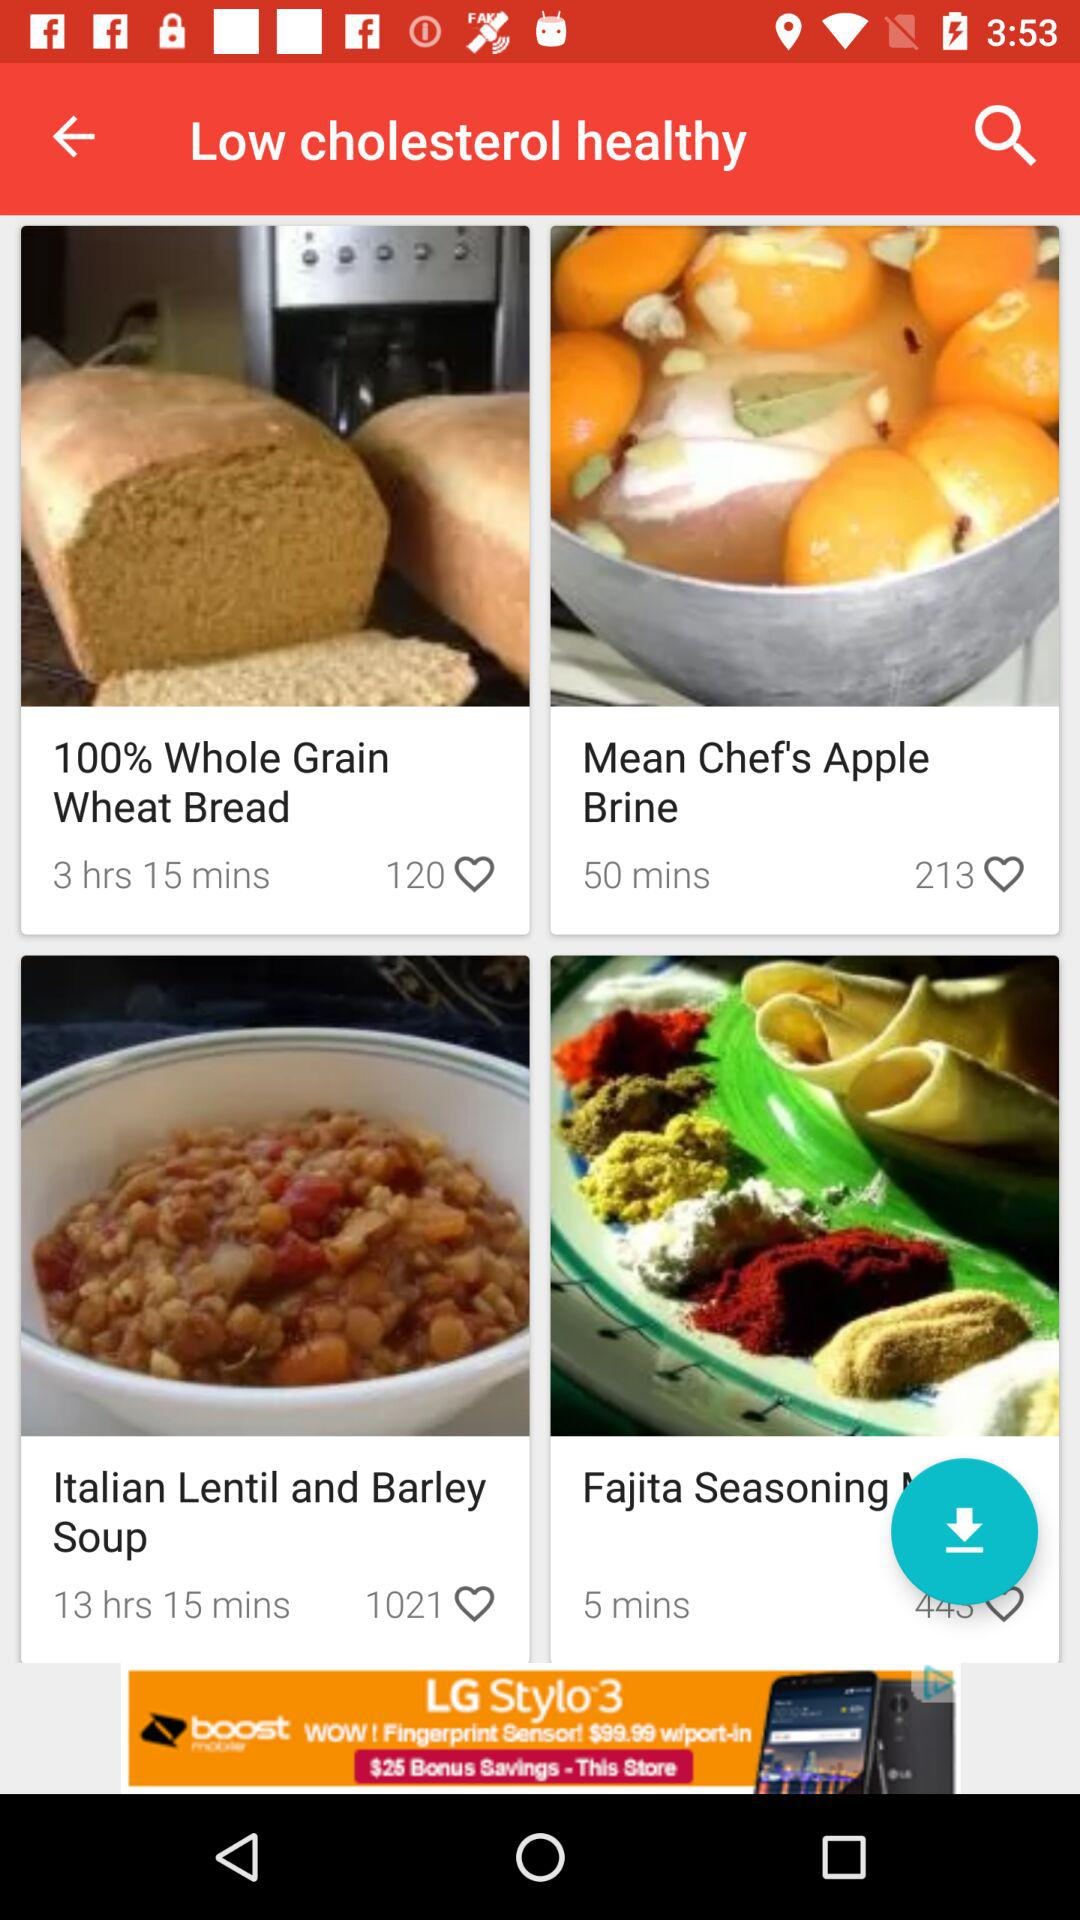What item has 120 likes? The item is "100% Whole Grain Wheat Bread". 